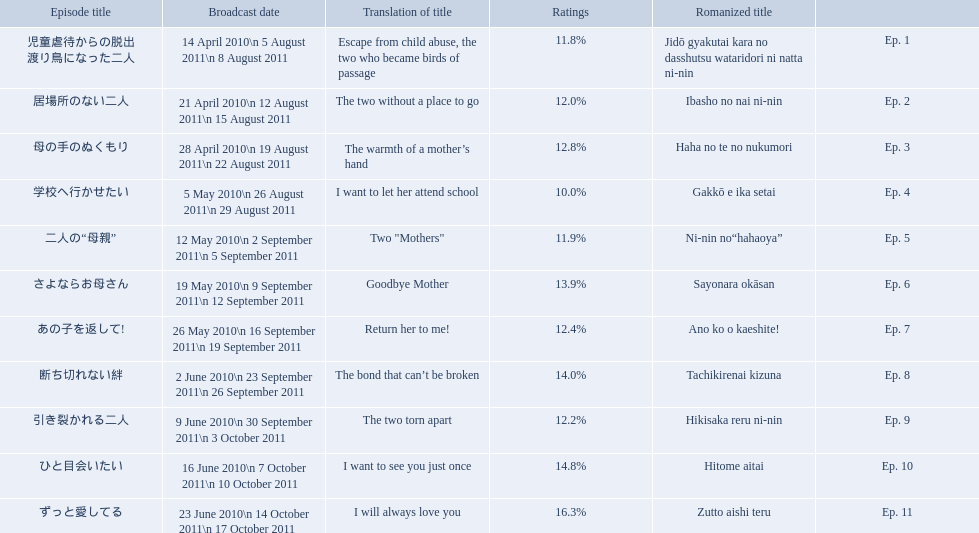What are the episode numbers? Ep. 1, Ep. 2, Ep. 3, Ep. 4, Ep. 5, Ep. 6, Ep. 7, Ep. 8, Ep. 9, Ep. 10, Ep. 11. What was the percentage of total ratings for episode 8? 14.0%. What were all the episode titles for the show mother? 児童虐待からの脱出 渡り鳥になった二人, 居場所のない二人, 母の手のぬくもり, 学校へ行かせたい, 二人の“母親”, さよならお母さん, あの子を返して!, 断ち切れない絆, 引き裂かれる二人, ひと目会いたい, ずっと愛してる. What were all the translated episode titles for the show mother? Escape from child abuse, the two who became birds of passage, The two without a place to go, The warmth of a mother’s hand, I want to let her attend school, Two "Mothers", Goodbye Mother, Return her to me!, The bond that can’t be broken, The two torn apart, I want to see you just once, I will always love you. Which episode was translated to i want to let her attend school? Ep. 4. 